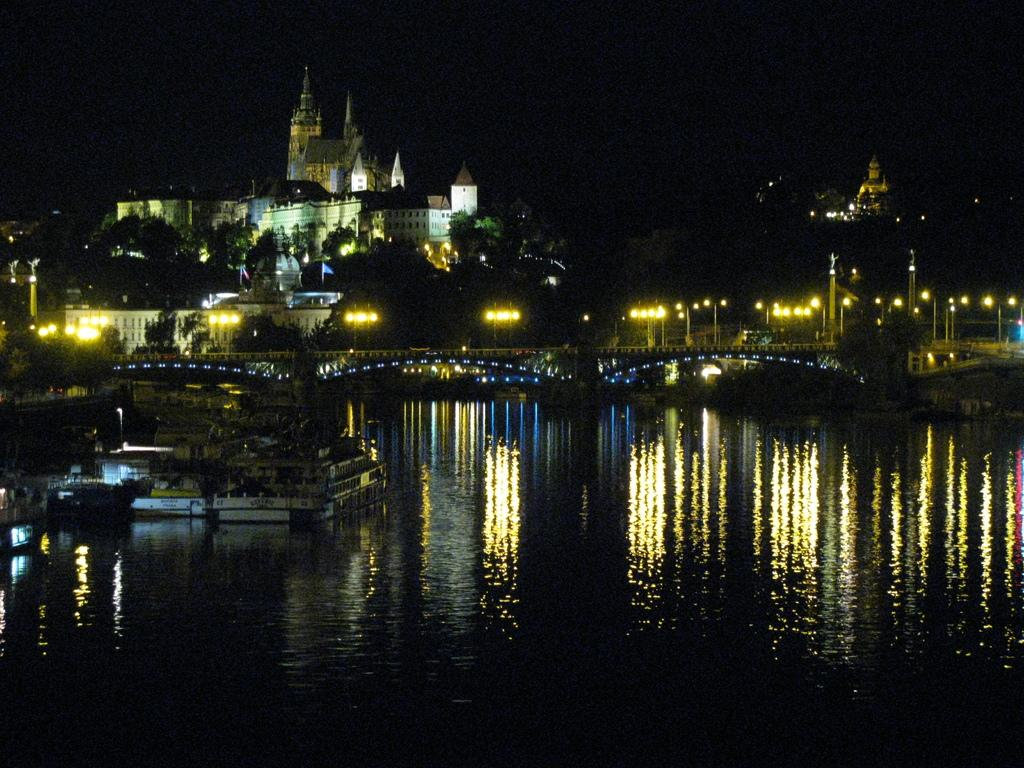What type of natural feature is present in the image? There is a lake in the image. What man-made structures can be seen in the image? There are street poles on a bridge, as well as buildings in the image. What type of vegetation is present in the image? There are trees in the image. What is visible at the top of the image? The sky is visible at the top of the image. Where is the market located in the image? There is no market present in the image. 